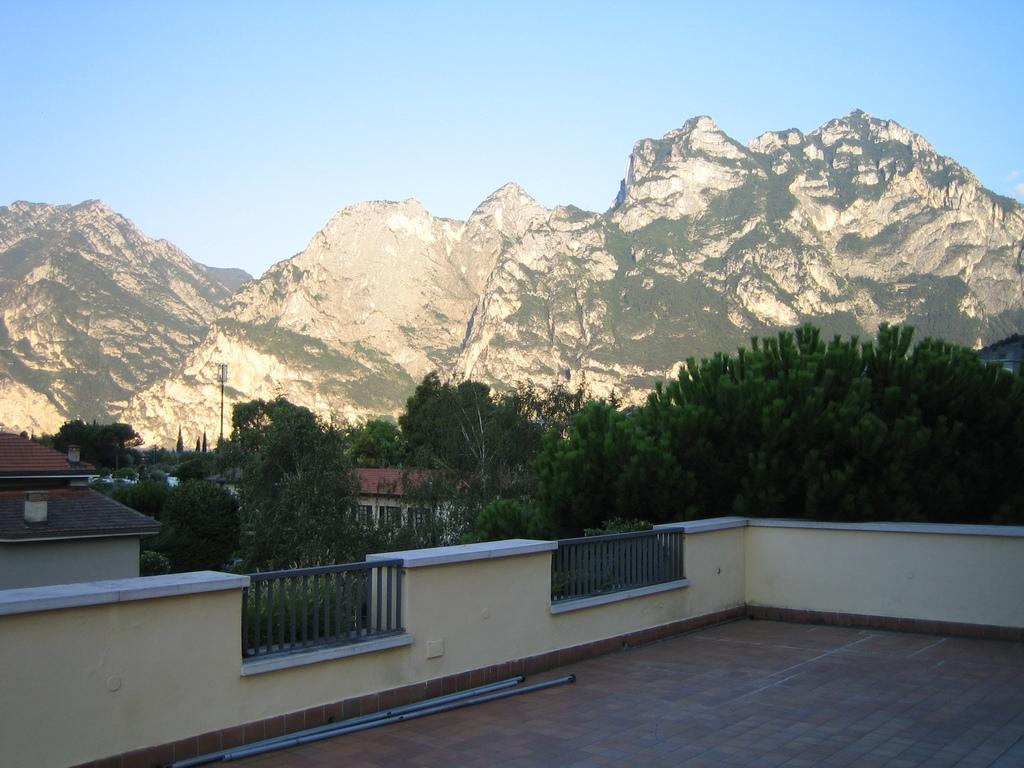How many pipes are on the floor in the image? There are three pipes on the floor in the image. What type of barrier can be seen in the image? There is a fence in the image. What structures can be seen in the background? There are houses, windows, trees, poles, and mountains visible in the background. What part of the natural environment is visible in the background? The sky is visible in the background. How does the parent's temper affect the spiders in the image? There are no parents, tempers, or spiders present in the image. 